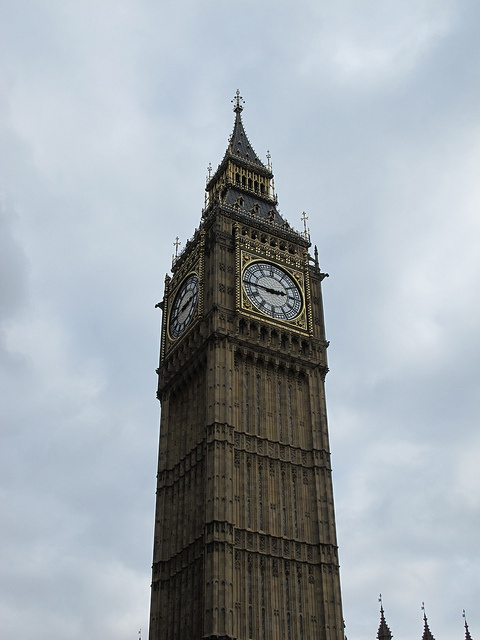Describe the objects in this image and their specific colors. I can see clock in lightgray, darkgray, gray, and black tones and clock in lightgray, black, and gray tones in this image. 